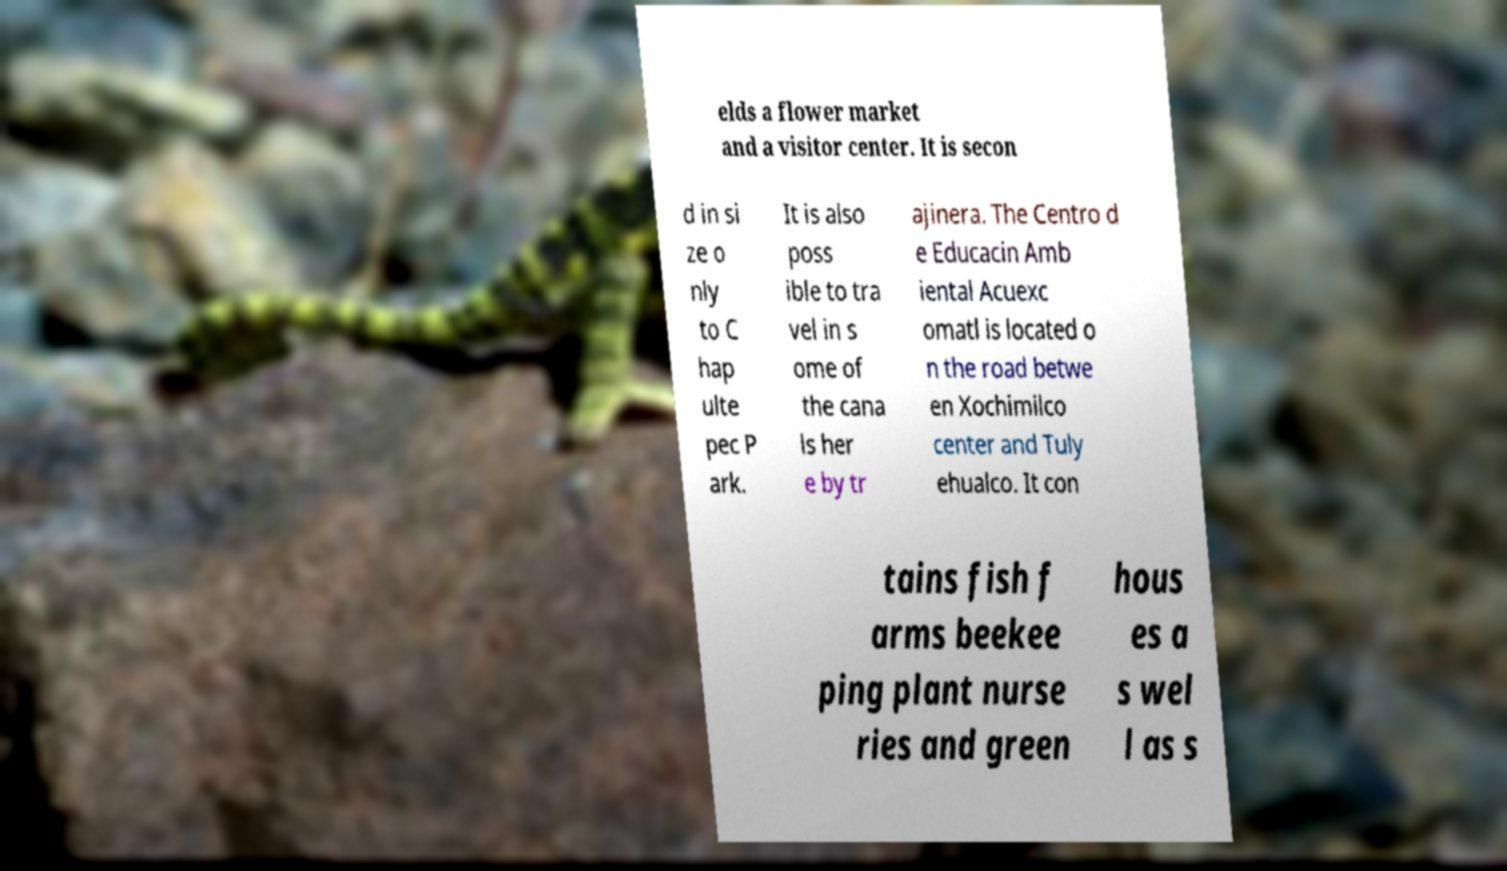Can you read and provide the text displayed in the image?This photo seems to have some interesting text. Can you extract and type it out for me? elds a flower market and a visitor center. It is secon d in si ze o nly to C hap ulte pec P ark. It is also poss ible to tra vel in s ome of the cana ls her e by tr ajinera. The Centro d e Educacin Amb iental Acuexc omatl is located o n the road betwe en Xochimilco center and Tuly ehualco. It con tains fish f arms beekee ping plant nurse ries and green hous es a s wel l as s 